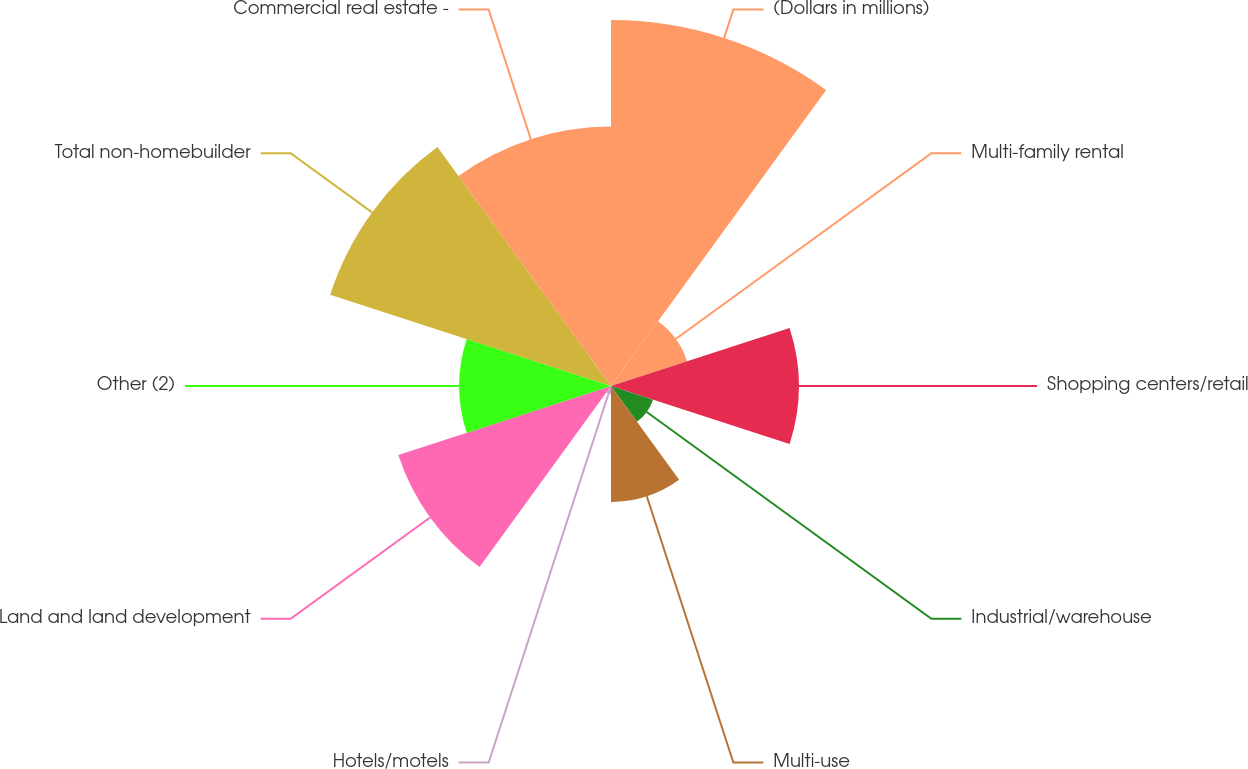Convert chart to OTSL. <chart><loc_0><loc_0><loc_500><loc_500><pie_chart><fcel>(Dollars in millions)<fcel>Multi-family rental<fcel>Shopping centers/retail<fcel>Industrial/warehouse<fcel>Multi-use<fcel>Hotels/motels<fcel>Land and land development<fcel>Other (2)<fcel>Total non-homebuilder<fcel>Commercial real estate -<nl><fcel>21.13%<fcel>4.62%<fcel>10.84%<fcel>2.55%<fcel>6.69%<fcel>0.47%<fcel>12.91%<fcel>8.76%<fcel>17.05%<fcel>14.98%<nl></chart> 